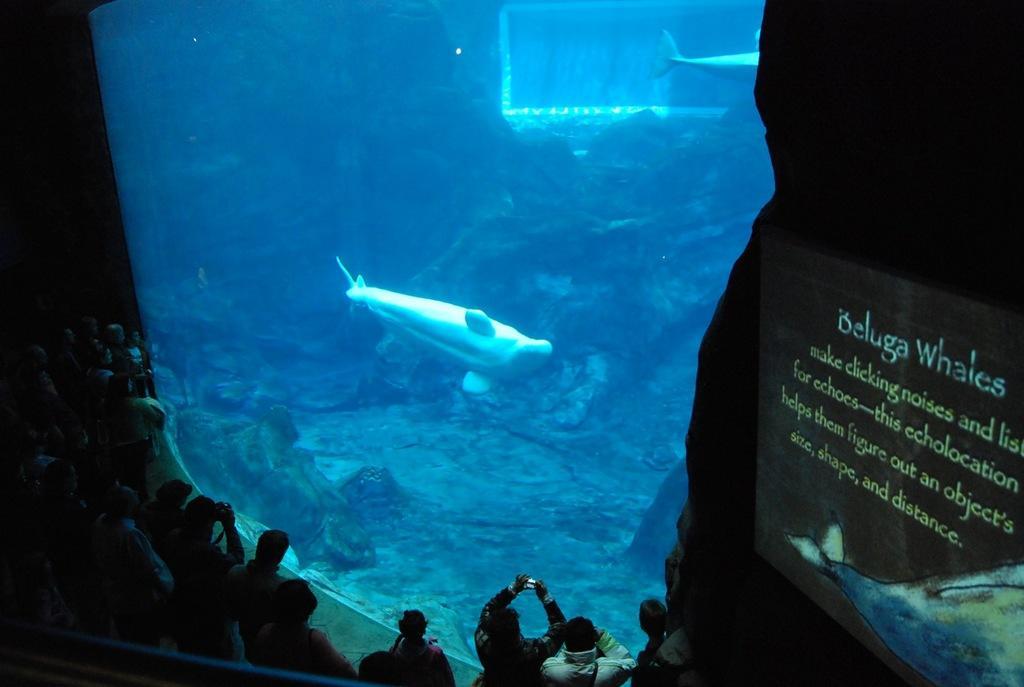Can you describe this image briefly? In this image there are people standing and few people are capturing photographs of a fish present in the aquarium. On the right there is a text on the board and there is also a fish diagram. 